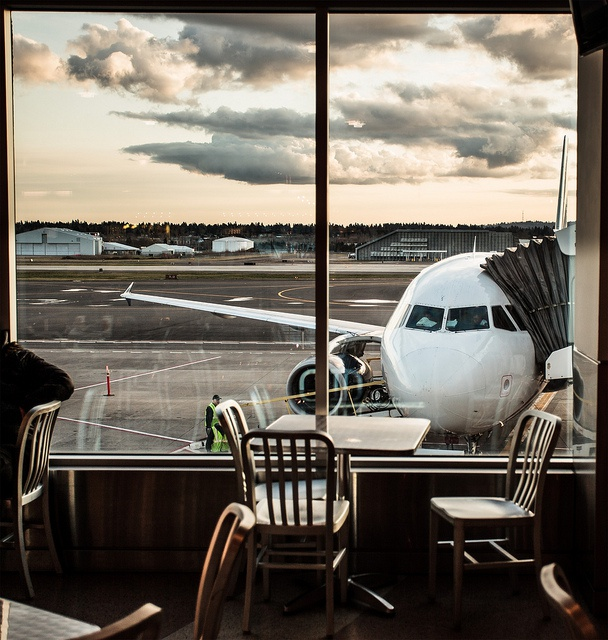Describe the objects in this image and their specific colors. I can see airplane in black, lightgray, darkgray, and gray tones, chair in black, darkgray, lightgray, and gray tones, chair in black, darkgray, lightgray, and gray tones, chair in black, gray, and tan tones, and dining table in black, lightgray, and darkgray tones in this image. 